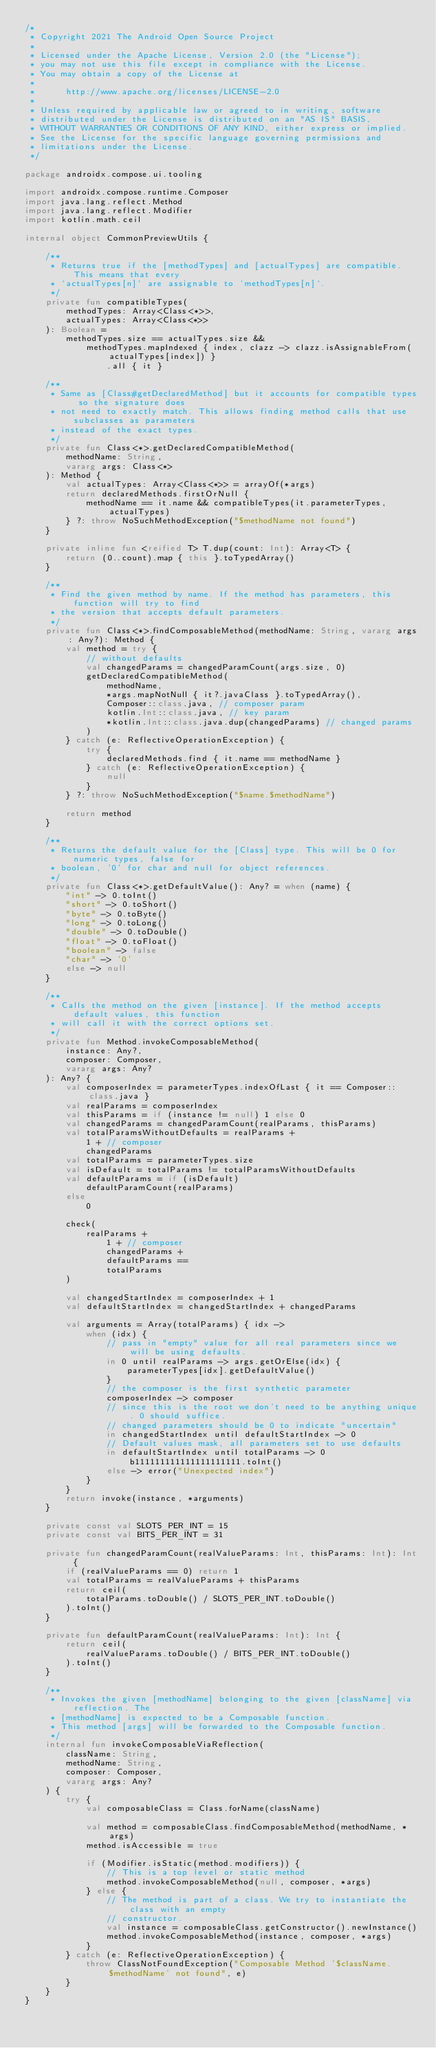Convert code to text. <code><loc_0><loc_0><loc_500><loc_500><_Kotlin_>/*
 * Copyright 2021 The Android Open Source Project
 *
 * Licensed under the Apache License, Version 2.0 (the "License");
 * you may not use this file except in compliance with the License.
 * You may obtain a copy of the License at
 *
 *      http://www.apache.org/licenses/LICENSE-2.0
 *
 * Unless required by applicable law or agreed to in writing, software
 * distributed under the License is distributed on an "AS IS" BASIS,
 * WITHOUT WARRANTIES OR CONDITIONS OF ANY KIND, either express or implied.
 * See the License for the specific language governing permissions and
 * limitations under the License.
 */

package androidx.compose.ui.tooling

import androidx.compose.runtime.Composer
import java.lang.reflect.Method
import java.lang.reflect.Modifier
import kotlin.math.ceil

internal object CommonPreviewUtils {

    /**
     * Returns true if the [methodTypes] and [actualTypes] are compatible. This means that every
     * `actualTypes[n]` are assignable to `methodTypes[n]`.
     */
    private fun compatibleTypes(
        methodTypes: Array<Class<*>>,
        actualTypes: Array<Class<*>>
    ): Boolean =
        methodTypes.size == actualTypes.size &&
            methodTypes.mapIndexed { index, clazz -> clazz.isAssignableFrom(actualTypes[index]) }
                .all { it }

    /**
     * Same as [Class#getDeclaredMethod] but it accounts for compatible types so the signature does
     * not need to exactly match. This allows finding method calls that use subclasses as parameters
     * instead of the exact types.
     */
    private fun Class<*>.getDeclaredCompatibleMethod(
        methodName: String,
        vararg args: Class<*>
    ): Method {
        val actualTypes: Array<Class<*>> = arrayOf(*args)
        return declaredMethods.firstOrNull {
            methodName == it.name && compatibleTypes(it.parameterTypes, actualTypes)
        } ?: throw NoSuchMethodException("$methodName not found")
    }

    private inline fun <reified T> T.dup(count: Int): Array<T> {
        return (0..count).map { this }.toTypedArray()
    }

    /**
     * Find the given method by name. If the method has parameters, this function will try to find
     * the version that accepts default parameters.
     */
    private fun Class<*>.findComposableMethod(methodName: String, vararg args: Any?): Method {
        val method = try {
            // without defaults
            val changedParams = changedParamCount(args.size, 0)
            getDeclaredCompatibleMethod(
                methodName,
                *args.mapNotNull { it?.javaClass }.toTypedArray(),
                Composer::class.java, // composer param
                kotlin.Int::class.java, // key param
                *kotlin.Int::class.java.dup(changedParams) // changed params
            )
        } catch (e: ReflectiveOperationException) {
            try {
                declaredMethods.find { it.name == methodName }
            } catch (e: ReflectiveOperationException) {
                null
            }
        } ?: throw NoSuchMethodException("$name.$methodName")

        return method
    }

    /**
     * Returns the default value for the [Class] type. This will be 0 for numeric types, false for
     * boolean, '0' for char and null for object references.
     */
    private fun Class<*>.getDefaultValue(): Any? = when (name) {
        "int" -> 0.toInt()
        "short" -> 0.toShort()
        "byte" -> 0.toByte()
        "long" -> 0.toLong()
        "double" -> 0.toDouble()
        "float" -> 0.toFloat()
        "boolean" -> false
        "char" -> '0'
        else -> null
    }

    /**
     * Calls the method on the given [instance]. If the method accepts default values, this function
     * will call it with the correct options set.
     */
    private fun Method.invokeComposableMethod(
        instance: Any?,
        composer: Composer,
        vararg args: Any?
    ): Any? {
        val composerIndex = parameterTypes.indexOfLast { it == Composer::class.java }
        val realParams = composerIndex
        val thisParams = if (instance != null) 1 else 0
        val changedParams = changedParamCount(realParams, thisParams)
        val totalParamsWithoutDefaults = realParams +
            1 + // composer
            changedParams
        val totalParams = parameterTypes.size
        val isDefault = totalParams != totalParamsWithoutDefaults
        val defaultParams = if (isDefault)
            defaultParamCount(realParams)
        else
            0

        check(
            realParams +
                1 + // composer
                changedParams +
                defaultParams ==
                totalParams
        )

        val changedStartIndex = composerIndex + 1
        val defaultStartIndex = changedStartIndex + changedParams

        val arguments = Array(totalParams) { idx ->
            when (idx) {
                // pass in "empty" value for all real parameters since we will be using defaults.
                in 0 until realParams -> args.getOrElse(idx) {
                    parameterTypes[idx].getDefaultValue()
                }
                // the composer is the first synthetic parameter
                composerIndex -> composer
                // since this is the root we don't need to be anything unique. 0 should suffice.
                // changed parameters should be 0 to indicate "uncertain"
                in changedStartIndex until defaultStartIndex -> 0
                // Default values mask, all parameters set to use defaults
                in defaultStartIndex until totalParams -> 0b111111111111111111111.toInt()
                else -> error("Unexpected index")
            }
        }
        return invoke(instance, *arguments)
    }

    private const val SLOTS_PER_INT = 15
    private const val BITS_PER_INT = 31

    private fun changedParamCount(realValueParams: Int, thisParams: Int): Int {
        if (realValueParams == 0) return 1
        val totalParams = realValueParams + thisParams
        return ceil(
            totalParams.toDouble() / SLOTS_PER_INT.toDouble()
        ).toInt()
    }

    private fun defaultParamCount(realValueParams: Int): Int {
        return ceil(
            realValueParams.toDouble() / BITS_PER_INT.toDouble()
        ).toInt()
    }

    /**
     * Invokes the given [methodName] belonging to the given [className] via reflection. The
     * [methodName] is expected to be a Composable function.
     * This method [args] will be forwarded to the Composable function.
     */
    internal fun invokeComposableViaReflection(
        className: String,
        methodName: String,
        composer: Composer,
        vararg args: Any?
    ) {
        try {
            val composableClass = Class.forName(className)

            val method = composableClass.findComposableMethod(methodName, *args)
            method.isAccessible = true

            if (Modifier.isStatic(method.modifiers)) {
                // This is a top level or static method
                method.invokeComposableMethod(null, composer, *args)
            } else {
                // The method is part of a class. We try to instantiate the class with an empty
                // constructor.
                val instance = composableClass.getConstructor().newInstance()
                method.invokeComposableMethod(instance, composer, *args)
            }
        } catch (e: ReflectiveOperationException) {
            throw ClassNotFoundException("Composable Method '$className.$methodName' not found", e)
        }
    }
}
</code> 